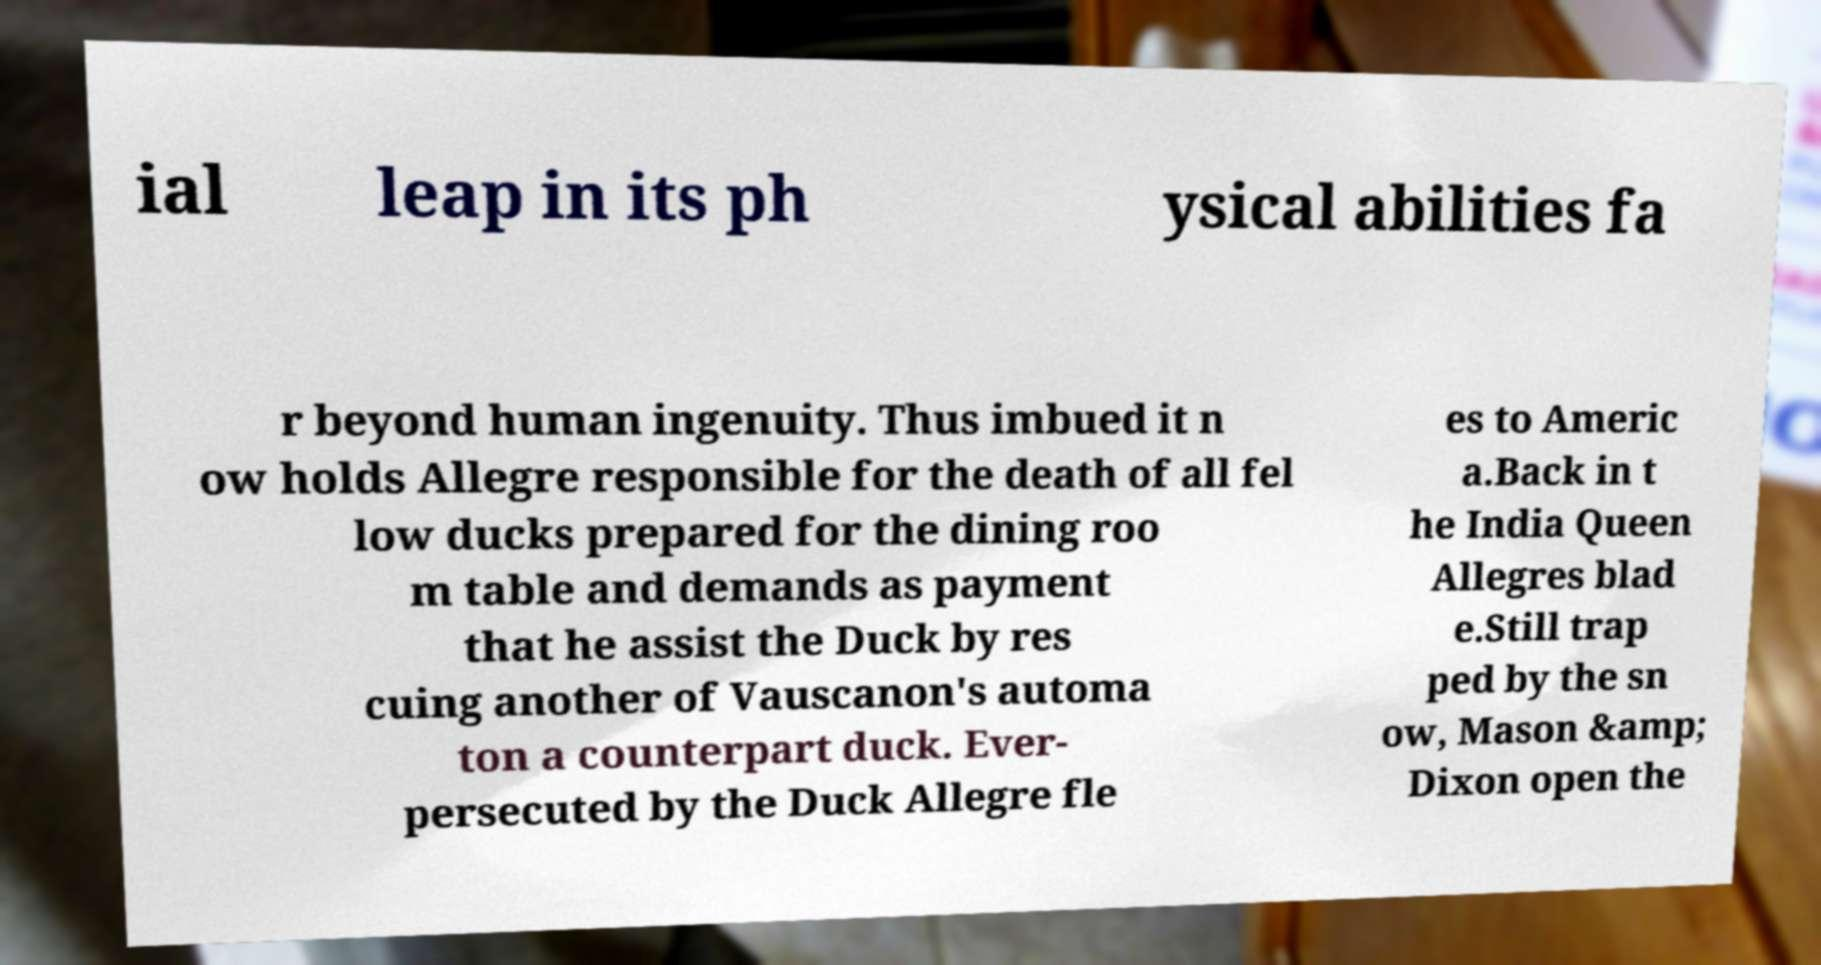Can you accurately transcribe the text from the provided image for me? ial leap in its ph ysical abilities fa r beyond human ingenuity. Thus imbued it n ow holds Allegre responsible for the death of all fel low ducks prepared for the dining roo m table and demands as payment that he assist the Duck by res cuing another of Vauscanon's automa ton a counterpart duck. Ever- persecuted by the Duck Allegre fle es to Americ a.Back in t he India Queen Allegres blad e.Still trap ped by the sn ow, Mason &amp; Dixon open the 